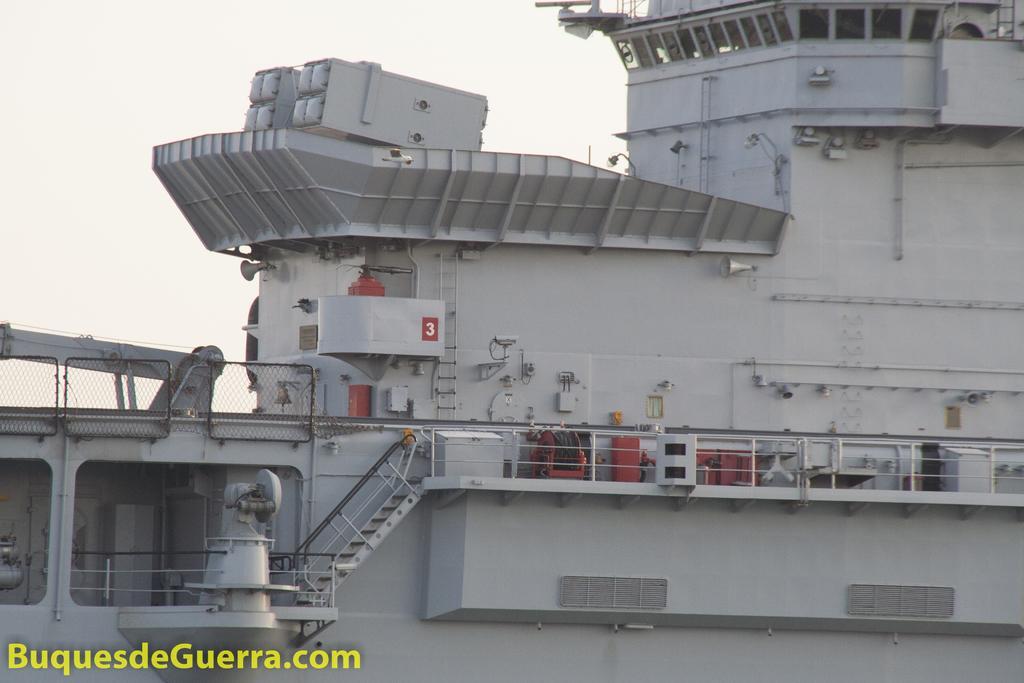Could you give a brief overview of what you see in this image? In this image we can see the ship with the railing and also stairs. In the bottom left corner we can see the text. In the background we can see the sky. 